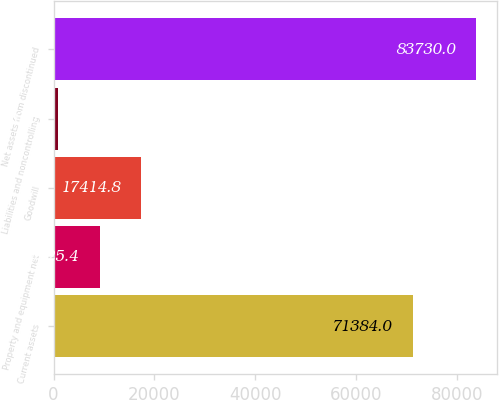<chart> <loc_0><loc_0><loc_500><loc_500><bar_chart><fcel>Current assets<fcel>Property and equipment net<fcel>Goodwill<fcel>Liabilities and noncontrolling<fcel>Net assets from discontinued<nl><fcel>71384<fcel>9125.4<fcel>17414.8<fcel>836<fcel>83730<nl></chart> 